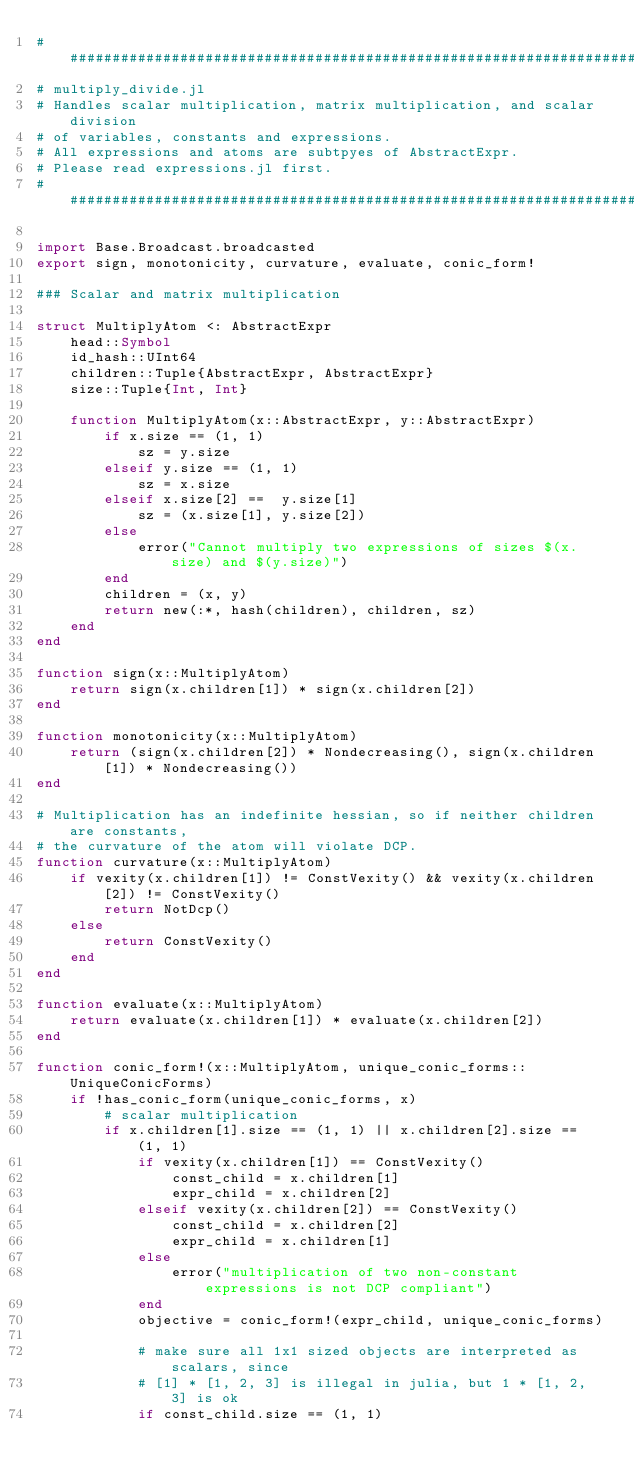<code> <loc_0><loc_0><loc_500><loc_500><_Julia_>#############################################################################
# multiply_divide.jl
# Handles scalar multiplication, matrix multiplication, and scalar division
# of variables, constants and expressions.
# All expressions and atoms are subtpyes of AbstractExpr.
# Please read expressions.jl first.
#############################################################################

import Base.Broadcast.broadcasted
export sign, monotonicity, curvature, evaluate, conic_form!

### Scalar and matrix multiplication

struct MultiplyAtom <: AbstractExpr
    head::Symbol
    id_hash::UInt64
    children::Tuple{AbstractExpr, AbstractExpr}
    size::Tuple{Int, Int}

    function MultiplyAtom(x::AbstractExpr, y::AbstractExpr)
        if x.size == (1, 1)
            sz = y.size
        elseif y.size == (1, 1)
            sz = x.size
        elseif x.size[2] ==  y.size[1]
            sz = (x.size[1], y.size[2])
        else
            error("Cannot multiply two expressions of sizes $(x.size) and $(y.size)")
        end
        children = (x, y)
        return new(:*, hash(children), children, sz)
    end
end

function sign(x::MultiplyAtom)
    return sign(x.children[1]) * sign(x.children[2])
end

function monotonicity(x::MultiplyAtom)
    return (sign(x.children[2]) * Nondecreasing(), sign(x.children[1]) * Nondecreasing())
end

# Multiplication has an indefinite hessian, so if neither children are constants,
# the curvature of the atom will violate DCP.
function curvature(x::MultiplyAtom)
    if vexity(x.children[1]) != ConstVexity() && vexity(x.children[2]) != ConstVexity()
        return NotDcp()
    else
        return ConstVexity()
    end
end

function evaluate(x::MultiplyAtom)
    return evaluate(x.children[1]) * evaluate(x.children[2])
end

function conic_form!(x::MultiplyAtom, unique_conic_forms::UniqueConicForms)
    if !has_conic_form(unique_conic_forms, x)
        # scalar multiplication
        if x.children[1].size == (1, 1) || x.children[2].size == (1, 1)
            if vexity(x.children[1]) == ConstVexity()
                const_child = x.children[1]
                expr_child = x.children[2]
            elseif vexity(x.children[2]) == ConstVexity()
                const_child = x.children[2]
                expr_child = x.children[1]
            else
                error("multiplication of two non-constant expressions is not DCP compliant")
            end
            objective = conic_form!(expr_child, unique_conic_forms)

            # make sure all 1x1 sized objects are interpreted as scalars, since
            # [1] * [1, 2, 3] is illegal in julia, but 1 * [1, 2, 3] is ok
            if const_child.size == (1, 1)</code> 